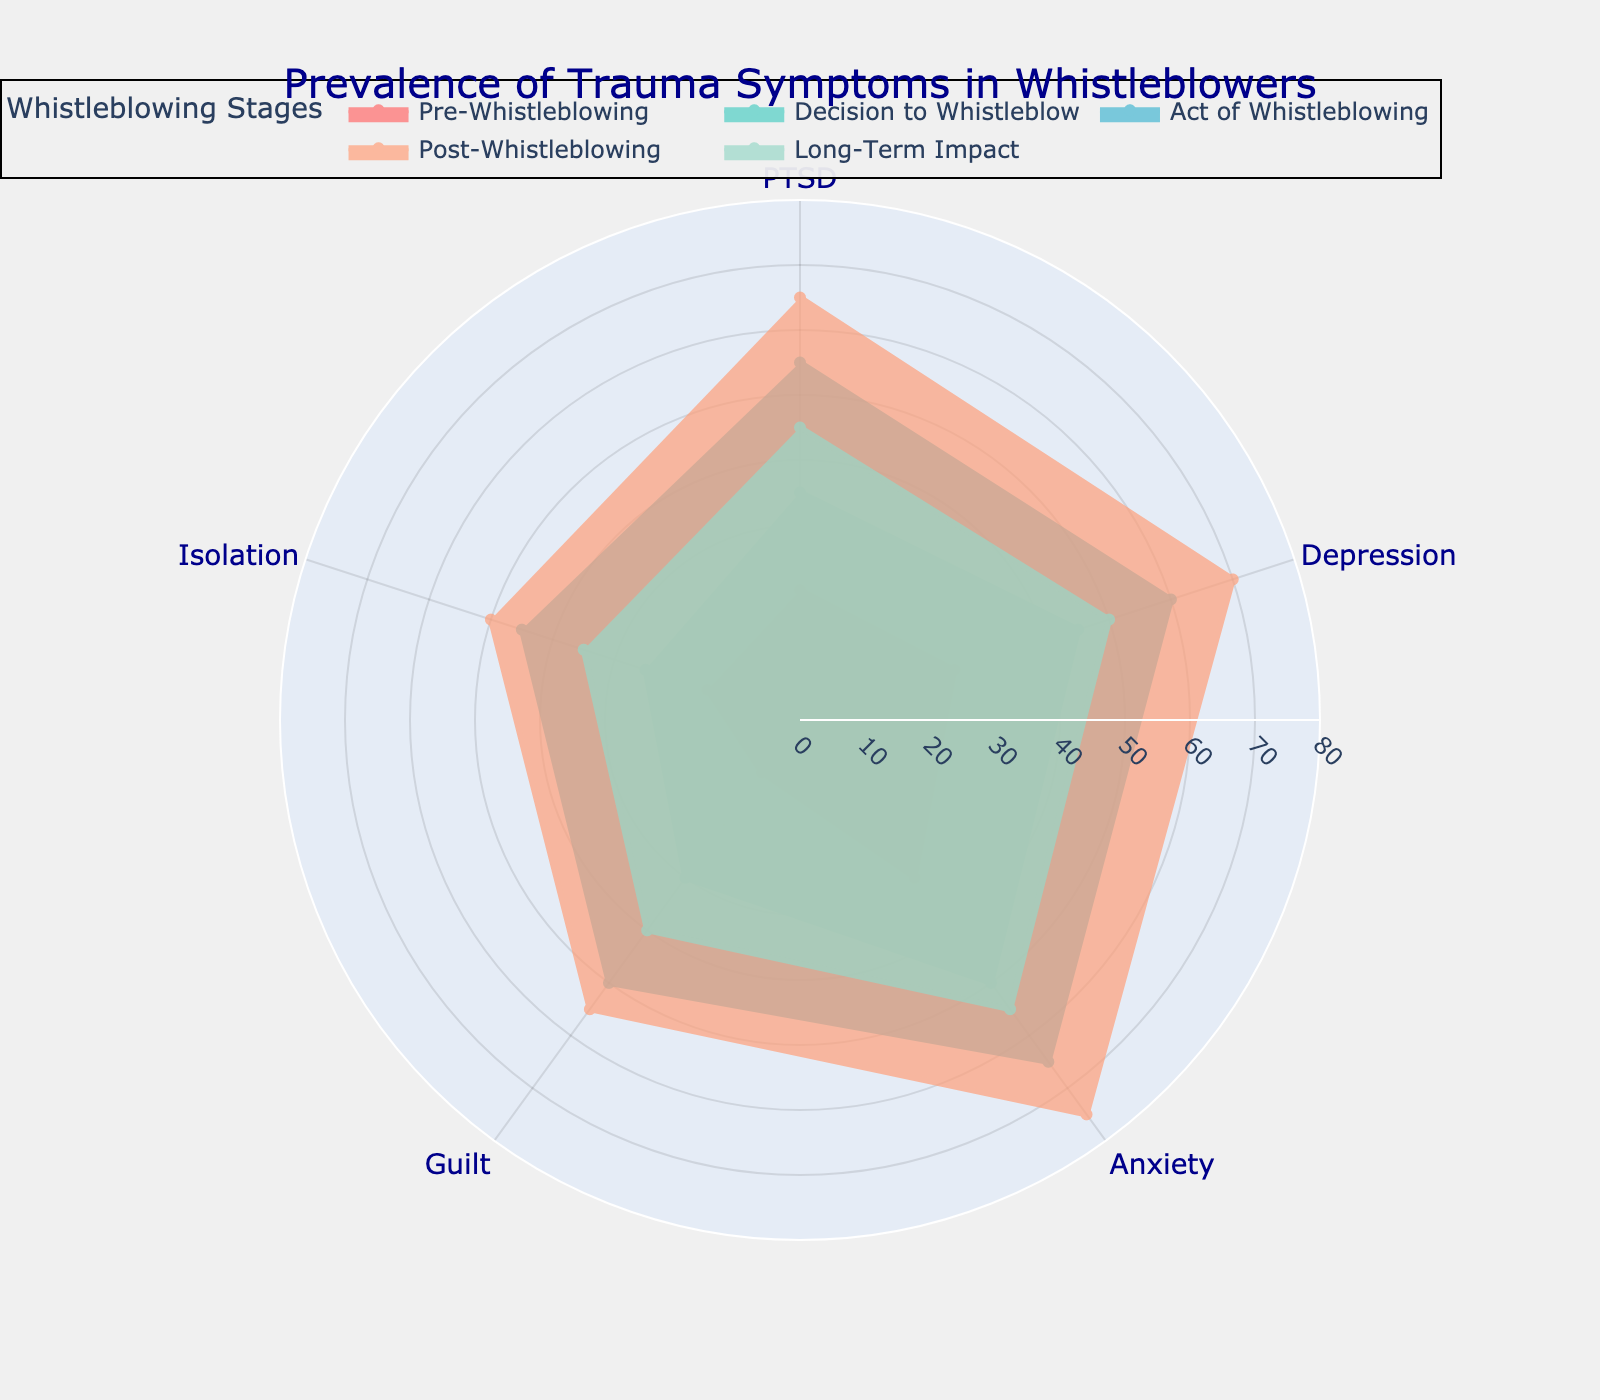What is the title of the figure? The title of the figure is displayed at the top and it summarizes the main topic of the plot. It says "Prevalence of Trauma Symptoms in Whistleblowers Across Stages of Whistleblowing Process".
Answer: Prevalence of Trauma Symptoms in Whistleblowers Across Stages of Whistleblowing Process Which trauma symptom has the highest value during the Post-Whistleblowing stage? By looking at the plot, locate the line corresponding to the "Post-Whistleblowing" stage and identify which symptom extends the furthest out. This represents the highest value. Anxiety has the highest value at this stage.
Answer: Anxiety What is the range of radial values displayed on the plot? The radial axis range can be observed from the markings on the axis that encircles the plot. It extends from 0 to 80.
Answer: 0 to 80 How does the prevalence of PTSD compare between the Pre-Whistleblowing and Long-Term Impact stages? Compare the radial length for PTSD between these two stages. PTSD is higher during the Long-Term Impact stage (45) than the Pre-Whistleblowing stage (20).
Answer: Higher in Long-Term Impact Which stage shows the highest overall prevalence of trauma symptoms? Overall prevalence can be determined by the maximum extent of the lines for each stage. The "Post-Whistleblowing" stage has the highest overall values extending out furthest for most symptoms.
Answer: Post-Whistleblowing On average, how do the trauma symptoms change from the Decision to Whistleblow stage to the Act of Whistleblowing stage? Average the values of each symptom for the "Decision to Whistleblow" and "Act of Whistleblowing" stages. Symptoms increase from the Decision to Whistleblow (35+45+50+30+25)/5 = 37 to Act of Whistleblowing (55+60+65+50+45)/5 = 55.
Answer: Increase Which symptom shows the largest change from Pre-Whistleblowing to the Post-Whistleblowing stage? Calculate the difference for each symptom between these two stages. The symptom with the highest difference: PTSD increases from 20 to 65, a change of 45. Depression increases by 45, Anxiety increases by 45, Guilt by 45, and Isolation by 35. Therefore, all symptoms increase significantly, equally for PTSD, Depression, Anxiety, and Guilt except for Isolation.
Answer: PTSD, Depression, Anxiety, and Guilt What color represents the "Long-Term Impact" stage in the plot? Refer to the line and fill color associated with the label "Long-Term Impact" in the legend. It is typically a distinct color from the others for clarity. The color is likely '#98D8C8'.
Answer: A light greenish color How does the prevalence of Guilt change from the Decision to Whistleblow to Long-Term Impact stage? Check the radial value for Guilt at both stages. Guilt increases from 30 in the Decision to Whistleblow stage to 40 in the Long-Term Impact stage.
Answer: Increases Overall, which symptom appears to be most impacted during the stages of the whistleblowing process? By examining the prevalence of each symptom across all stages, you can identify which has the most significant changes. Anxiety generally has the highest values across multiple stages.
Answer: Anxiety 